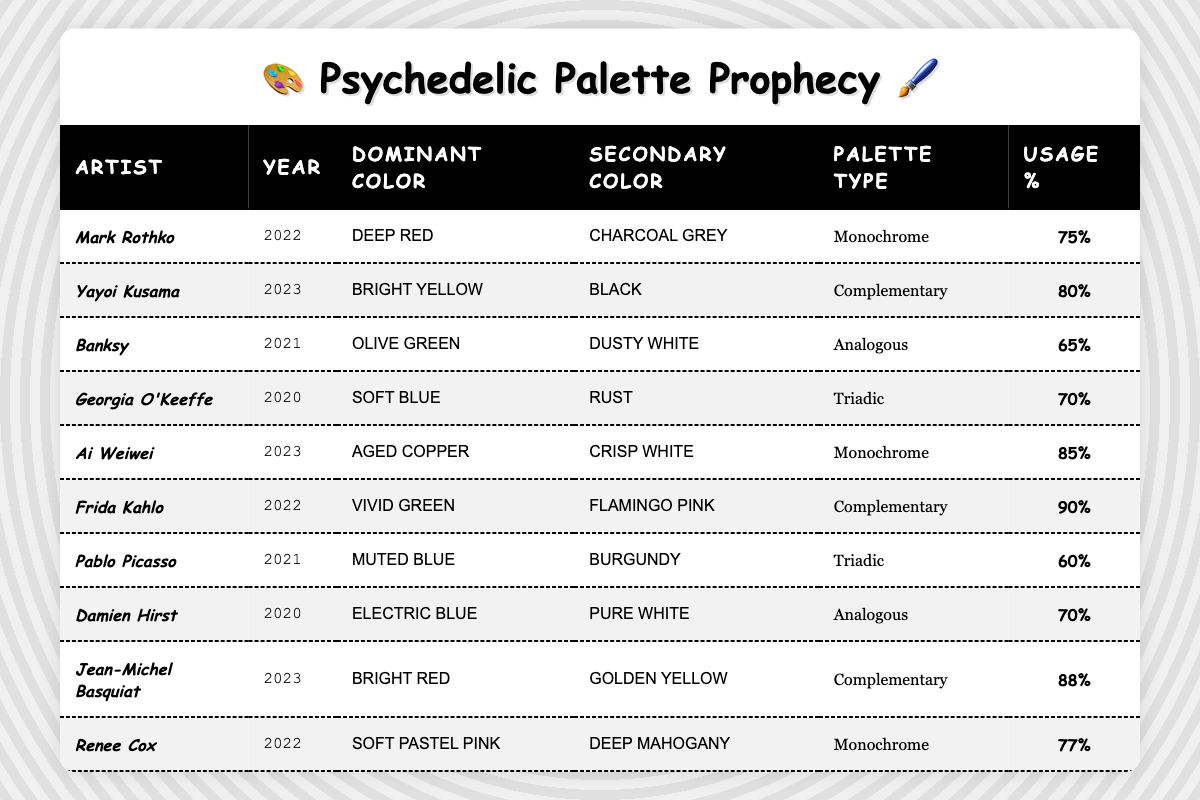What is the dominant color used by Frida Kahlo in 2022? According to the table, Frida Kahlo's dominant color in 2022 is listed as Vivid Green.
Answer: Vivid Green Which artist has the highest color usage percentage? By reviewing the table, the artist with the highest usage percentage is Frida Kahlo at 90%.
Answer: Frida Kahlo Is Ai Weiwei's color palette monochrome? The table indicates that Ai Weiwei's palette type is Monochrome, so the answer is yes.
Answer: Yes What is the average usage percentage for artists using a complementary color palette? The usage percentages for complementary palettes are 80% (Yayoi Kusama), 90% (Frida Kahlo), and 88% (Jean-Michel Basquiat). The average is (80 + 90 + 88) / 3 = 86%, calculated by adding the three usage percentages and dividing by the number of artists.
Answer: 86% Which palette type was used by Banksy in 2021, and what was the usage percentage? The table shows that Banksy used an Analogous palette type with a usage percentage of 65%.
Answer: Analogous, 65% How many artists used monochrome palettes? The table lists three artists (Mark Rothko, Ai Weiwei, and Renee Cox) who used monochrome palettes.
Answer: 3 Which artist had both the highest secondary color usage and the lowest dominant color usage? Frida Kahlo has the highest secondary color usage (Flamingo Pink at 90%), while Banksy has the lowest dominant color usage (Olive Green at 65%). This involves checking the dominant colors and usage percentages across the artists.
Answer: Frida Kahlo (highest) and Banksy (lowest) What is the difference in usage percentage between the strongest and weakest artist in terms of color palette usage? The strongest usage percentage is Frida Kahlo at 90%, and the weakest belongs to Pablo Picasso at 60%. The difference is 90 - 60 = 30%.
Answer: 30% Which year saw the most diverse palette types among artists? The table shows different artists and their palette types for each year: 2020 (Triadic, Analogous), 2021 (Analogous, Triadic), 2022 (Monochrome, Complementary), and 2023 (Monochrome, Complementary). 2022 has Monochrome and Complementary, while 2021 has Analogous and Triadic, leading to 2023 being less diverse. 2021 showcases two distinct types, but 2022 includes a singular type. Cumulatively, all years provide variations.
Answer: 2021 